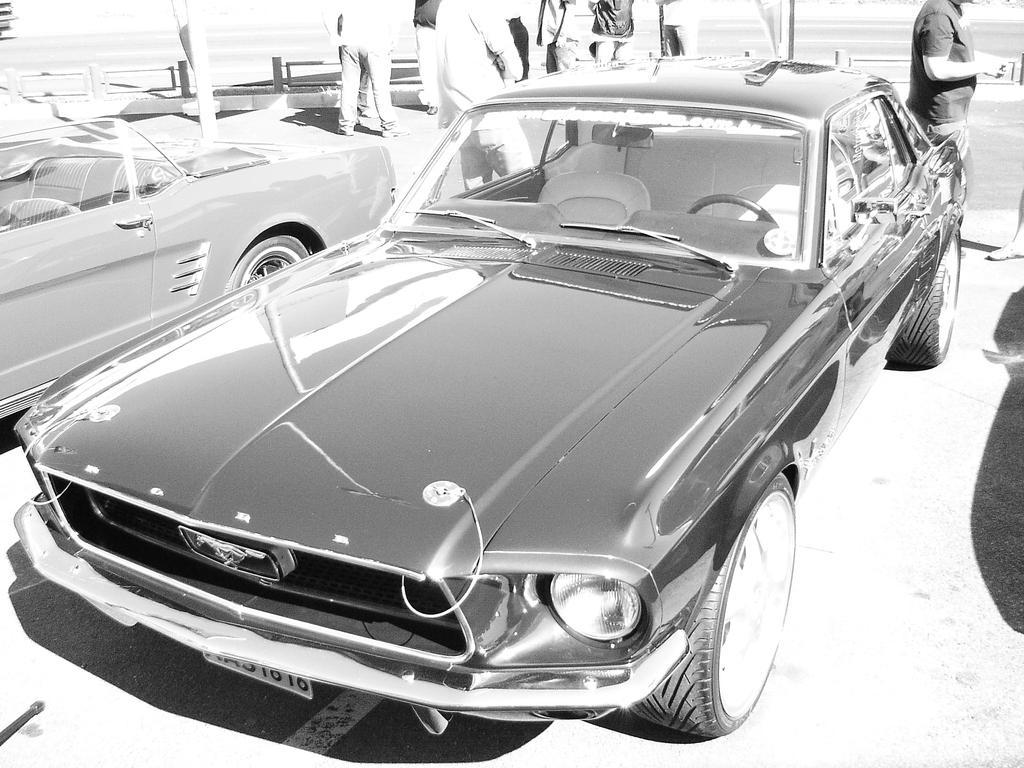Could you give a brief overview of what you see in this image? In this image there is road, there are a group of persons towards the top of the image, there are cars on the road, the background of the image is white in color. 